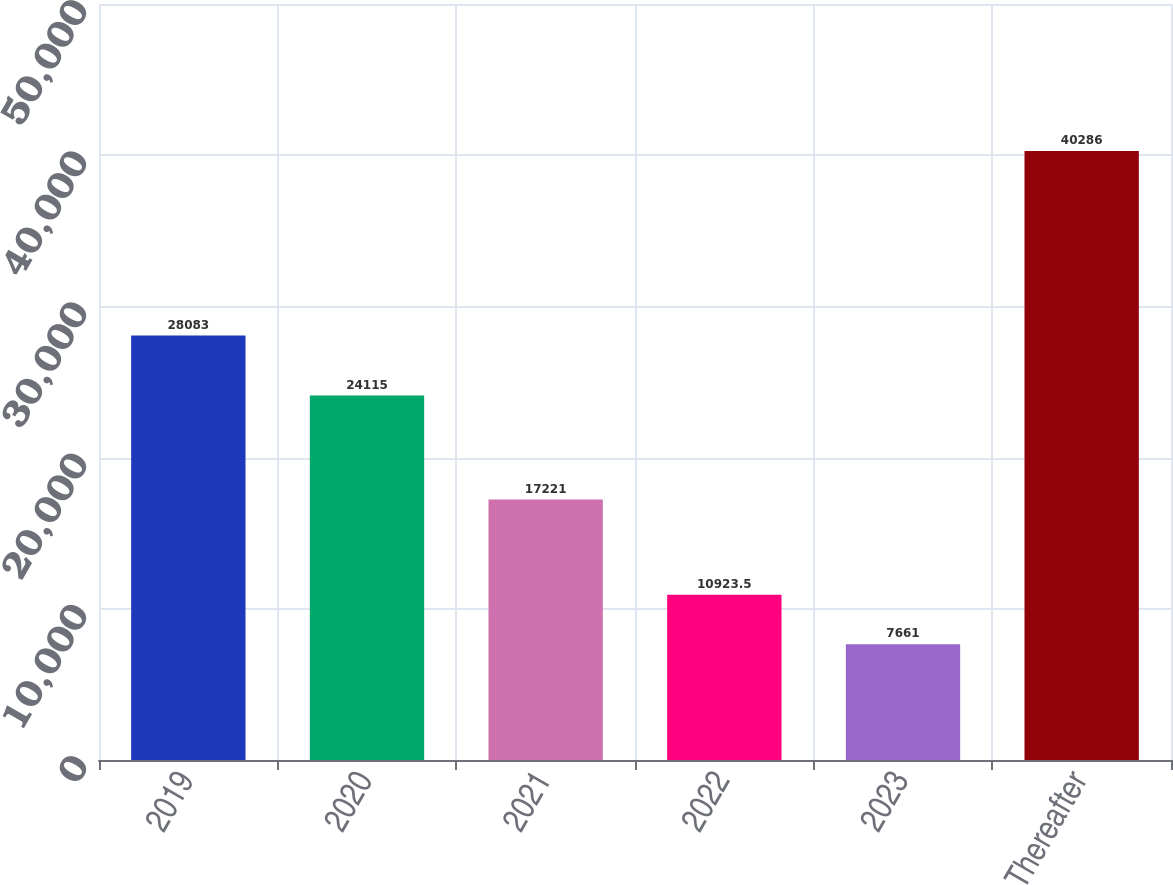<chart> <loc_0><loc_0><loc_500><loc_500><bar_chart><fcel>2019<fcel>2020<fcel>2021<fcel>2022<fcel>2023<fcel>Thereafter<nl><fcel>28083<fcel>24115<fcel>17221<fcel>10923.5<fcel>7661<fcel>40286<nl></chart> 